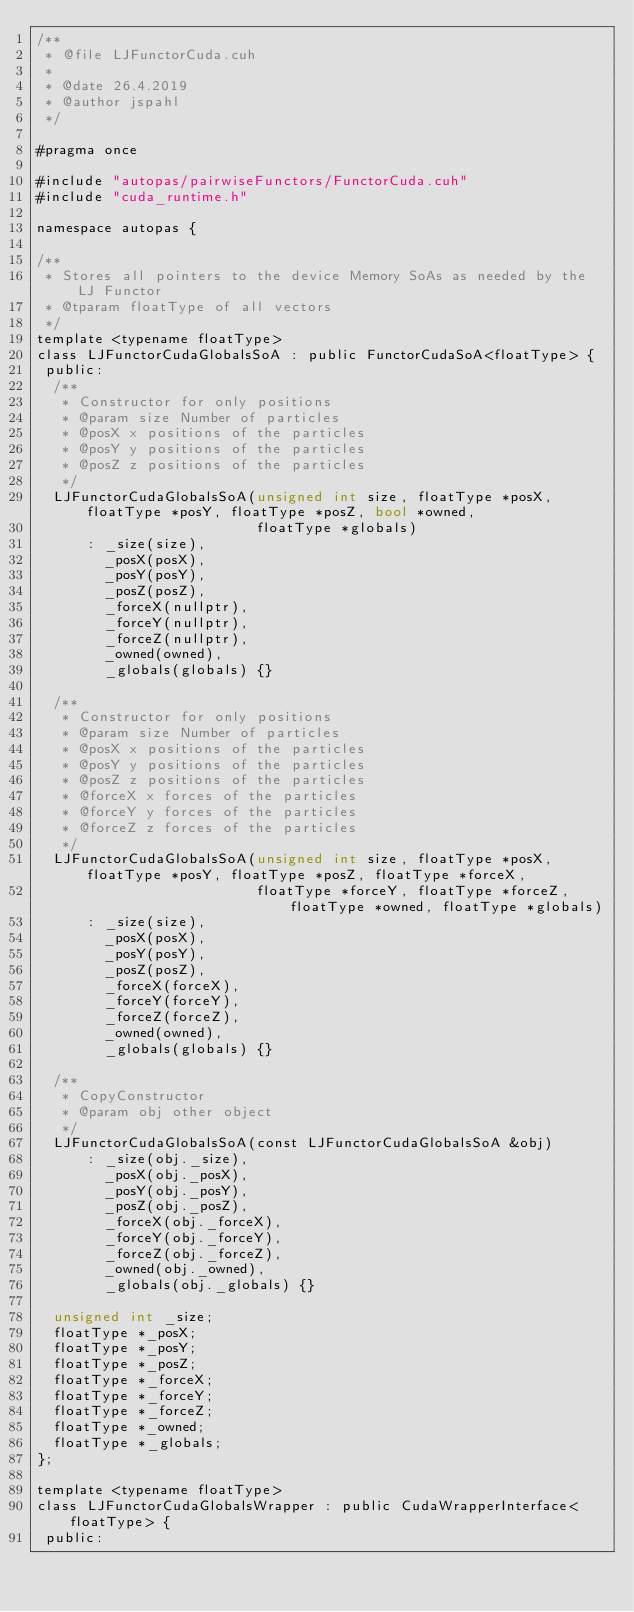<code> <loc_0><loc_0><loc_500><loc_500><_Cuda_>/**
 * @file LJFunctorCuda.cuh
 *
 * @date 26.4.2019
 * @author jspahl
 */

#pragma once

#include "autopas/pairwiseFunctors/FunctorCuda.cuh"
#include "cuda_runtime.h"

namespace autopas {

/**
 * Stores all pointers to the device Memory SoAs as needed by the LJ Functor
 * @tparam floatType of all vectors
 */
template <typename floatType>
class LJFunctorCudaGlobalsSoA : public FunctorCudaSoA<floatType> {
 public:
  /**
   * Constructor for only positions
   * @param size Number of particles
   * @posX x positions of the particles
   * @posY y positions of the particles
   * @posZ z positions of the particles
   */
  LJFunctorCudaGlobalsSoA(unsigned int size, floatType *posX, floatType *posY, floatType *posZ, bool *owned,
                          floatType *globals)
      : _size(size),
        _posX(posX),
        _posY(posY),
        _posZ(posZ),
        _forceX(nullptr),
        _forceY(nullptr),
        _forceZ(nullptr),
        _owned(owned),
        _globals(globals) {}

  /**
   * Constructor for only positions
   * @param size Number of particles
   * @posX x positions of the particles
   * @posY y positions of the particles
   * @posZ z positions of the particles
   * @forceX x forces of the particles
   * @forceY y forces of the particles
   * @forceZ z forces of the particles
   */
  LJFunctorCudaGlobalsSoA(unsigned int size, floatType *posX, floatType *posY, floatType *posZ, floatType *forceX,
                          floatType *forceY, floatType *forceZ, floatType *owned, floatType *globals)
      : _size(size),
        _posX(posX),
        _posY(posY),
        _posZ(posZ),
        _forceX(forceX),
        _forceY(forceY),
        _forceZ(forceZ),
        _owned(owned),
        _globals(globals) {}

  /**
   * CopyConstructor
   * @param obj other object
   */
  LJFunctorCudaGlobalsSoA(const LJFunctorCudaGlobalsSoA &obj)
      : _size(obj._size),
        _posX(obj._posX),
        _posY(obj._posY),
        _posZ(obj._posZ),
        _forceX(obj._forceX),
        _forceY(obj._forceY),
        _forceZ(obj._forceZ),
        _owned(obj._owned),
        _globals(obj._globals) {}

  unsigned int _size;
  floatType *_posX;
  floatType *_posY;
  floatType *_posZ;
  floatType *_forceX;
  floatType *_forceY;
  floatType *_forceZ;
  floatType *_owned;
  floatType *_globals;
};

template <typename floatType>
class LJFunctorCudaGlobalsWrapper : public CudaWrapperInterface<floatType> {
 public:</code> 